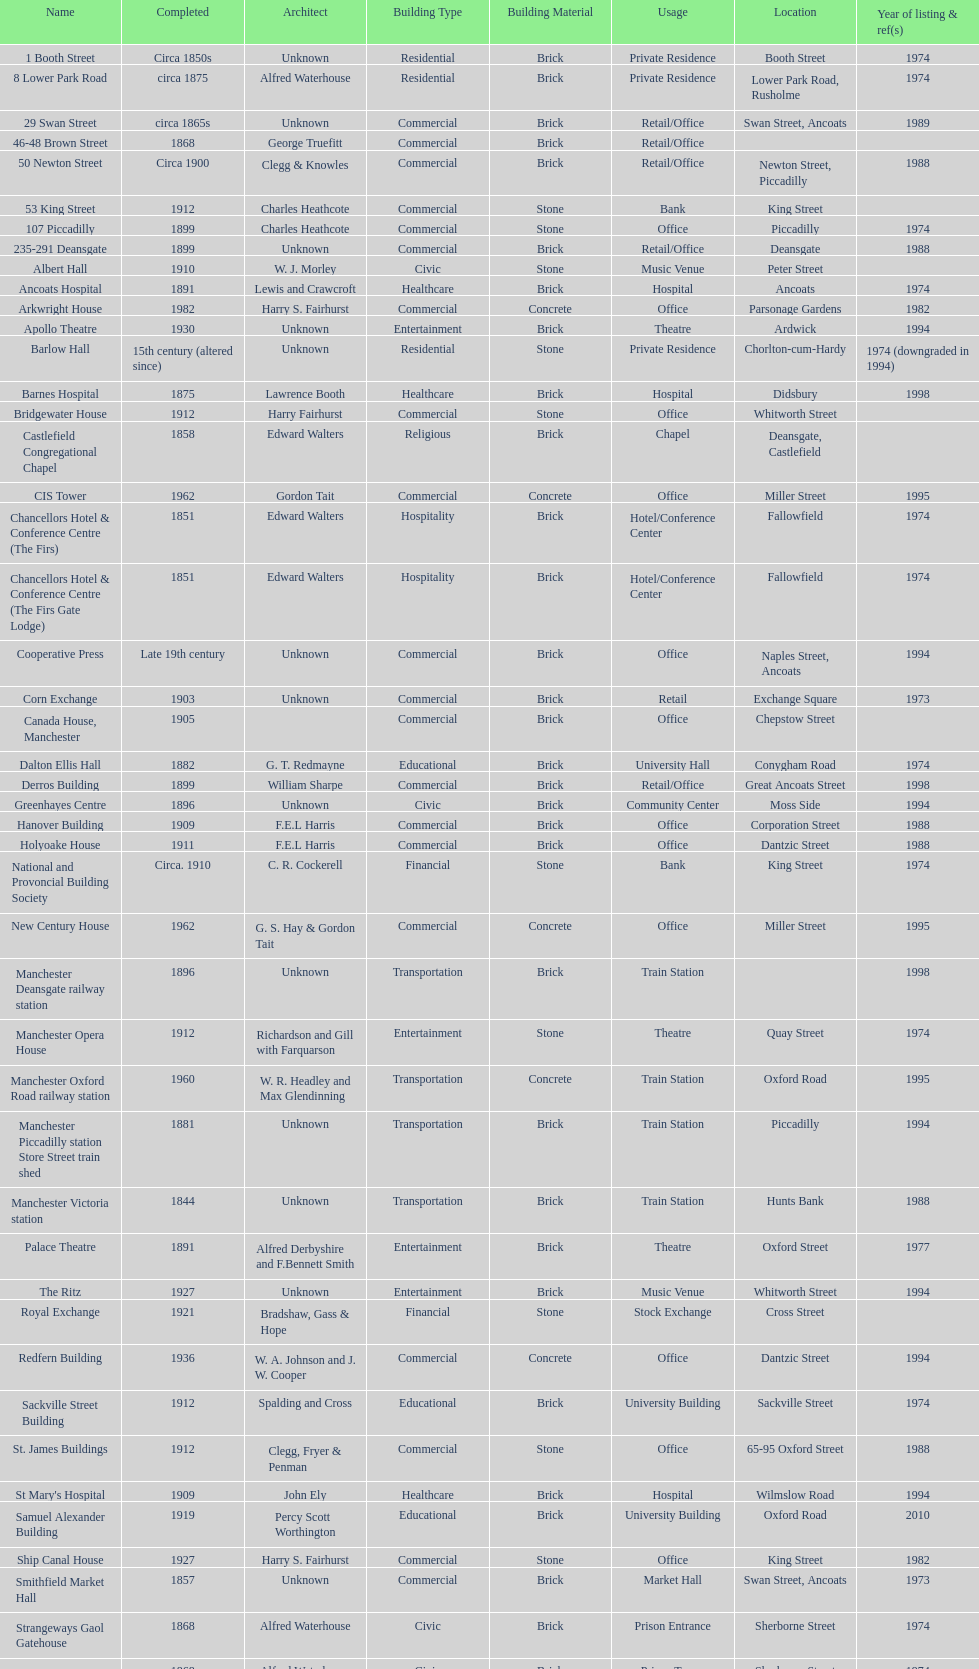Could you parse the entire table? {'header': ['Name', 'Completed', 'Architect', 'Building Type', 'Building Material', 'Usage', 'Location', 'Year of listing & ref(s)'], 'rows': [['1 Booth Street', 'Circa 1850s', 'Unknown', 'Residential', 'Brick', 'Private Residence', 'Booth Street', '1974'], ['8 Lower Park Road', 'circa 1875', 'Alfred Waterhouse', 'Residential', 'Brick', 'Private Residence', 'Lower Park Road, Rusholme', '1974'], ['29 Swan Street', 'circa 1865s', 'Unknown', 'Commercial', 'Brick', 'Retail/Office', 'Swan Street, Ancoats', '1989'], ['46-48 Brown Street', '1868', 'George Truefitt', 'Commercial', 'Brick', 'Retail/Office', '', ''], ['50 Newton Street', 'Circa 1900', 'Clegg & Knowles', 'Commercial', 'Brick', 'Retail/Office', 'Newton Street, Piccadilly', '1988'], ['53 King Street', '1912', 'Charles Heathcote', 'Commercial', 'Stone', 'Bank', 'King Street', ''], ['107 Piccadilly', '1899', 'Charles Heathcote', 'Commercial', 'Stone', 'Office', 'Piccadilly', '1974'], ['235-291 Deansgate', '1899', 'Unknown', 'Commercial', 'Brick', 'Retail/Office', 'Deansgate', '1988'], ['Albert Hall', '1910', 'W. J. Morley', 'Civic', 'Stone', 'Music Venue', 'Peter Street', ''], ['Ancoats Hospital', '1891', 'Lewis and Crawcroft', 'Healthcare', 'Brick', 'Hospital', 'Ancoats', '1974'], ['Arkwright House', '1982', 'Harry S. Fairhurst', 'Commercial', 'Concrete', 'Office', 'Parsonage Gardens', '1982'], ['Apollo Theatre', '1930', 'Unknown', 'Entertainment', 'Brick', 'Theatre', 'Ardwick', '1994'], ['Barlow Hall', '15th century (altered since)', 'Unknown', 'Residential', 'Stone', 'Private Residence', 'Chorlton-cum-Hardy', '1974 (downgraded in 1994)'], ['Barnes Hospital', '1875', 'Lawrence Booth', 'Healthcare', 'Brick', 'Hospital', 'Didsbury', '1998'], ['Bridgewater House', '1912', 'Harry Fairhurst', 'Commercial', 'Stone', 'Office', 'Whitworth Street', ''], ['Castlefield Congregational Chapel', '1858', 'Edward Walters', 'Religious', 'Brick', 'Chapel', 'Deansgate, Castlefield', ''], ['CIS Tower', '1962', 'Gordon Tait', 'Commercial', 'Concrete', 'Office', 'Miller Street', '1995'], ['Chancellors Hotel & Conference Centre (The Firs)', '1851', 'Edward Walters', 'Hospitality', 'Brick', 'Hotel/Conference Center', 'Fallowfield', '1974'], ['Chancellors Hotel & Conference Centre (The Firs Gate Lodge)', '1851', 'Edward Walters', 'Hospitality', 'Brick', 'Hotel/Conference Center', 'Fallowfield', '1974'], ['Cooperative Press', 'Late 19th century', 'Unknown', 'Commercial', 'Brick', 'Office', 'Naples Street, Ancoats', '1994'], ['Corn Exchange', '1903', 'Unknown', 'Commercial', 'Brick', 'Retail', 'Exchange Square', '1973'], ['Canada House, Manchester', '1905', '', 'Commercial', 'Brick', 'Office', 'Chepstow Street', ''], ['Dalton Ellis Hall', '1882', 'G. T. Redmayne', 'Educational', 'Brick', 'University Hall', 'Conygham Road', '1974'], ['Derros Building', '1899', 'William Sharpe', 'Commercial', 'Brick', 'Retail/Office', 'Great Ancoats Street', '1998'], ['Greenhayes Centre', '1896', 'Unknown', 'Civic', 'Brick', 'Community Center', 'Moss Side', '1994'], ['Hanover Building', '1909', 'F.E.L Harris', 'Commercial', 'Brick', 'Office', 'Corporation Street', '1988'], ['Holyoake House', '1911', 'F.E.L Harris', 'Commercial', 'Brick', 'Office', 'Dantzic Street', '1988'], ['National and Provoncial Building Society', 'Circa. 1910', 'C. R. Cockerell', 'Financial', 'Stone', 'Bank', 'King Street', '1974'], ['New Century House', '1962', 'G. S. Hay & Gordon Tait', 'Commercial', 'Concrete', 'Office', 'Miller Street', '1995'], ['Manchester Deansgate railway station', '1896', 'Unknown', 'Transportation', 'Brick', 'Train Station', '', '1998'], ['Manchester Opera House', '1912', 'Richardson and Gill with Farquarson', 'Entertainment', 'Stone', 'Theatre', 'Quay Street', '1974'], ['Manchester Oxford Road railway station', '1960', 'W. R. Headley and Max Glendinning', 'Transportation', 'Concrete', 'Train Station', 'Oxford Road', '1995'], ['Manchester Piccadilly station Store Street train shed', '1881', 'Unknown', 'Transportation', 'Brick', 'Train Station', 'Piccadilly', '1994'], ['Manchester Victoria station', '1844', 'Unknown', 'Transportation', 'Brick', 'Train Station', 'Hunts Bank', '1988'], ['Palace Theatre', '1891', 'Alfred Derbyshire and F.Bennett Smith', 'Entertainment', 'Brick', 'Theatre', 'Oxford Street', '1977'], ['The Ritz', '1927', 'Unknown', 'Entertainment', 'Brick', 'Music Venue', 'Whitworth Street', '1994'], ['Royal Exchange', '1921', 'Bradshaw, Gass & Hope', 'Financial', 'Stone', 'Stock Exchange', 'Cross Street', ''], ['Redfern Building', '1936', 'W. A. Johnson and J. W. Cooper', 'Commercial', 'Concrete', 'Office', 'Dantzic Street', '1994'], ['Sackville Street Building', '1912', 'Spalding and Cross', 'Educational', 'Brick', 'University Building', 'Sackville Street', '1974'], ['St. James Buildings', '1912', 'Clegg, Fryer & Penman', 'Commercial', 'Stone', 'Office', '65-95 Oxford Street', '1988'], ["St Mary's Hospital", '1909', 'John Ely', 'Healthcare', 'Brick', 'Hospital', 'Wilmslow Road', '1994'], ['Samuel Alexander Building', '1919', 'Percy Scott Worthington', 'Educational', 'Brick', 'University Building', 'Oxford Road', '2010'], ['Ship Canal House', '1927', 'Harry S. Fairhurst', 'Commercial', 'Stone', 'Office', 'King Street', '1982'], ['Smithfield Market Hall', '1857', 'Unknown', 'Commercial', 'Brick', 'Market Hall', 'Swan Street, Ancoats', '1973'], ['Strangeways Gaol Gatehouse', '1868', 'Alfred Waterhouse', 'Civic', 'Brick', 'Prison Entrance', 'Sherborne Street', '1974'], ['Strangeways Prison ventilation and watch tower', '1868', 'Alfred Waterhouse', 'Civic', 'Brick', 'Prison Tower', 'Sherborne Street', '1974'], ['Theatre Royal', '1845', 'Irwin and Chester', 'Entertainment', 'Stone', 'Theatre', 'Peter Street', '1974'], ['Toast Rack', '1960', 'L. C. Howitt', 'Educational', 'Concrete', 'University Building', 'Fallowfield', '1999'], ['The Old Wellington Inn', 'Mid-16th century', 'Unknown', 'Hospitality', 'Timber', 'Pub', 'Shambles Square', '1952'], ['Whitworth Park Mansions', 'Circa 1840s', 'Unknown', 'Residential', 'Brick', 'Private Residence', 'Whitworth Park', '1974']]} What is the street of the only building listed in 1989? Swan Street. 